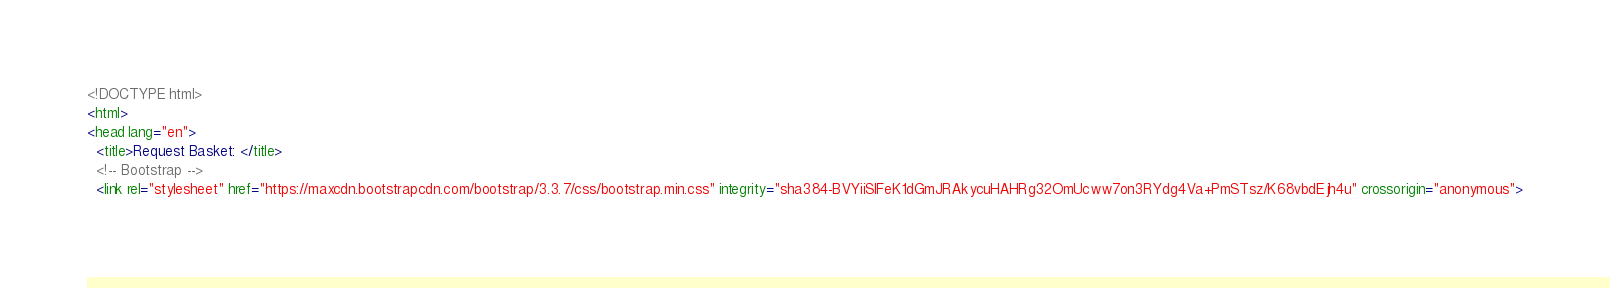Convert code to text. <code><loc_0><loc_0><loc_500><loc_500><_HTML_><!DOCTYPE html>
<html>
<head lang="en">
  <title>Request Basket: </title>
  <!-- Bootstrap -->
  <link rel="stylesheet" href="https://maxcdn.bootstrapcdn.com/bootstrap/3.3.7/css/bootstrap.min.css" integrity="sha384-BVYiiSIFeK1dGmJRAkycuHAHRg32OmUcww7on3RYdg4Va+PmSTsz/K68vbdEjh4u" crossorigin="anonymous"></code> 